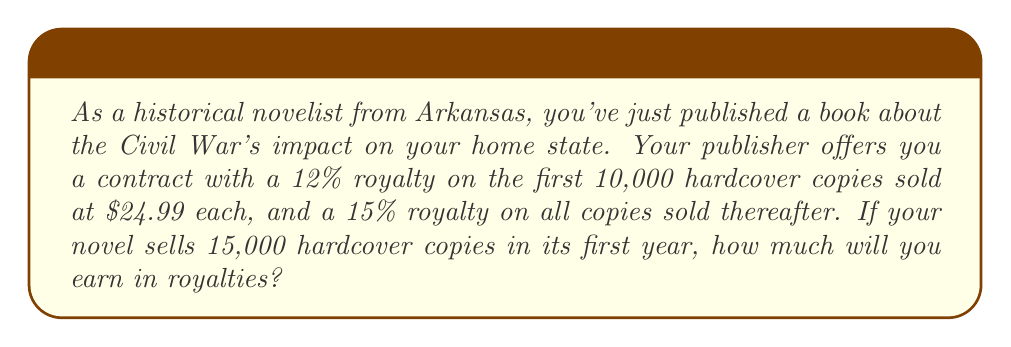Provide a solution to this math problem. Let's break this problem down into steps:

1. Calculate royalties for the first 10,000 copies:
   $$R_1 = 10000 \times 24.99 \times 0.12 = $29,988$$

2. Calculate royalties for the remaining 5,000 copies:
   $$R_2 = 5000 \times 24.99 \times 0.15 = $18,742.50$$

3. Sum up the total royalties:
   $$R_{total} = R_1 + R_2 = $29,988 + $18,742.50 = $48,730.50$$

The linear equations involved in this problem are:
$$y_1 = 0.12x$$ for the first 10,000 copies, where $x$ is the sale price and $y_1$ is the royalty per book.
$$y_2 = 0.15x$$ for copies sold after 10,000, where $x$ is the sale price and $y_2$ is the royalty per book.

The total royalty can be expressed as:
$$R_{total} = 10000y_1 + 5000y_2$$

Substituting the values:
$$R_{total} = 10000(0.12 \times 24.99) + 5000(0.15 \times 24.99)$$

This equation represents the linear combination of the two royalty rates applied to their respective quantities of books sold.
Answer: $48,730.50 